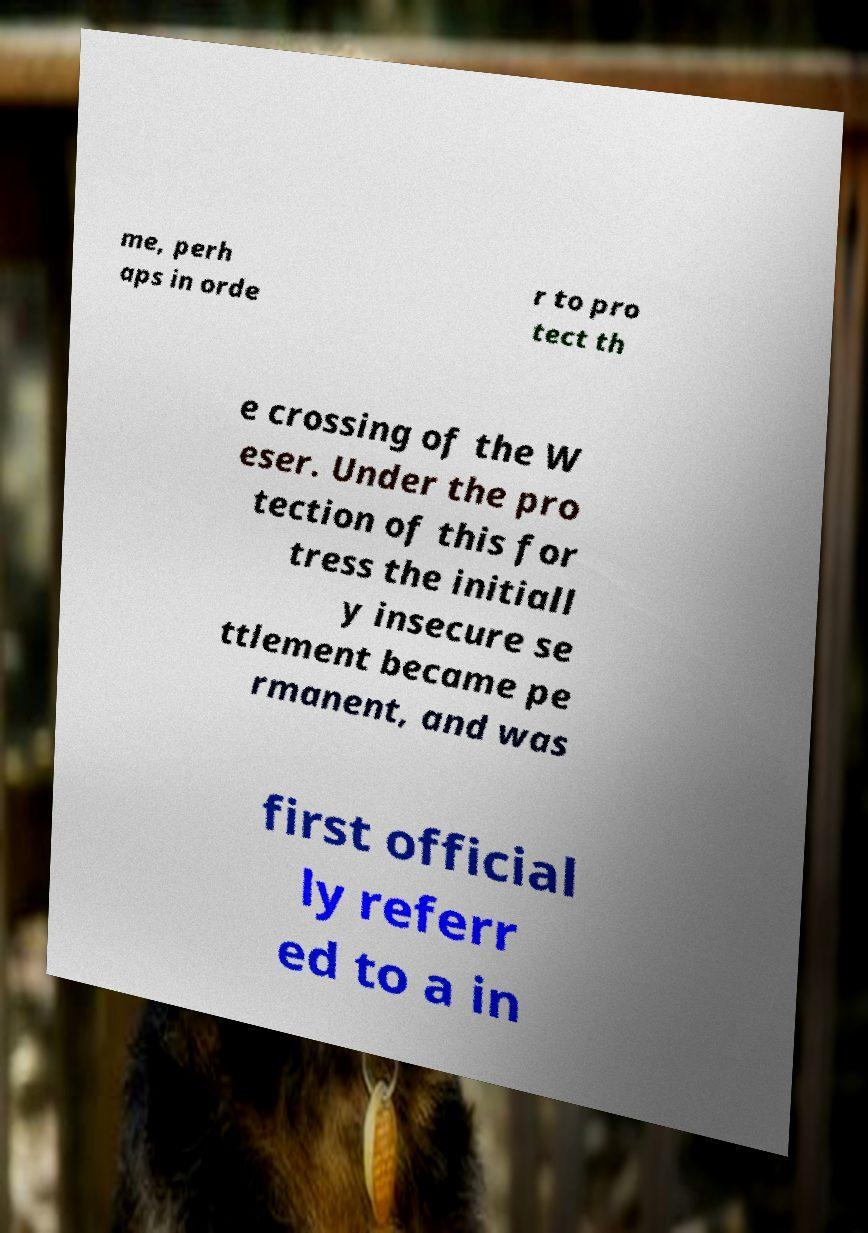There's text embedded in this image that I need extracted. Can you transcribe it verbatim? me, perh aps in orde r to pro tect th e crossing of the W eser. Under the pro tection of this for tress the initiall y insecure se ttlement became pe rmanent, and was first official ly referr ed to a in 